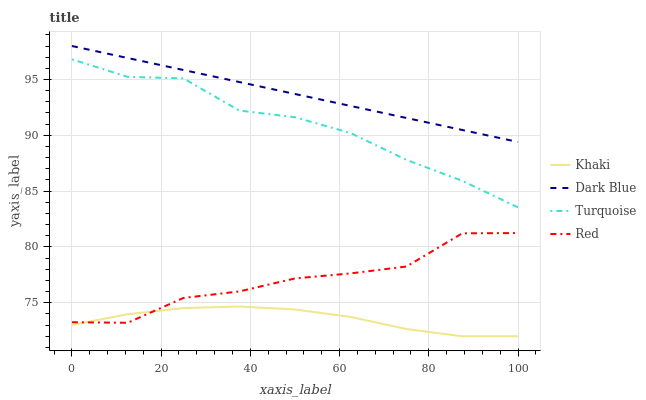Does Khaki have the minimum area under the curve?
Answer yes or no. Yes. Does Dark Blue have the maximum area under the curve?
Answer yes or no. Yes. Does Turquoise have the minimum area under the curve?
Answer yes or no. No. Does Turquoise have the maximum area under the curve?
Answer yes or no. No. Is Dark Blue the smoothest?
Answer yes or no. Yes. Is Red the roughest?
Answer yes or no. Yes. Is Turquoise the smoothest?
Answer yes or no. No. Is Turquoise the roughest?
Answer yes or no. No. Does Khaki have the lowest value?
Answer yes or no. Yes. Does Turquoise have the lowest value?
Answer yes or no. No. Does Dark Blue have the highest value?
Answer yes or no. Yes. Does Turquoise have the highest value?
Answer yes or no. No. Is Khaki less than Turquoise?
Answer yes or no. Yes. Is Dark Blue greater than Turquoise?
Answer yes or no. Yes. Does Khaki intersect Red?
Answer yes or no. Yes. Is Khaki less than Red?
Answer yes or no. No. Is Khaki greater than Red?
Answer yes or no. No. Does Khaki intersect Turquoise?
Answer yes or no. No. 